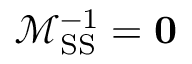<formula> <loc_0><loc_0><loc_500><loc_500>\mathcal { M } _ { S S } ^ { - 1 } = 0</formula> 